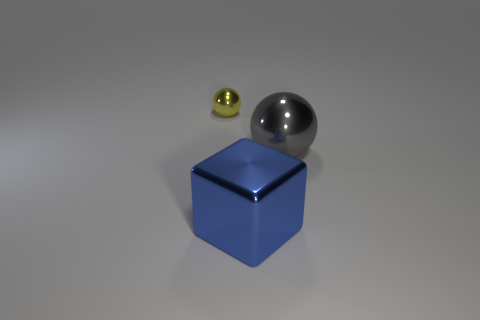Add 1 big brown metallic things. How many objects exist? 4 Subtract all spheres. How many objects are left? 1 Subtract 0 purple cylinders. How many objects are left? 3 Subtract all cubes. Subtract all cubes. How many objects are left? 1 Add 2 tiny yellow spheres. How many tiny yellow spheres are left? 3 Add 1 tiny gray rubber cylinders. How many tiny gray rubber cylinders exist? 1 